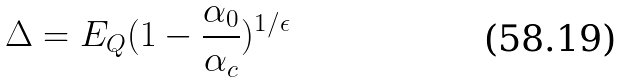Convert formula to latex. <formula><loc_0><loc_0><loc_500><loc_500>\Delta = E _ { Q } ( 1 - \frac { \alpha _ { 0 } } { \alpha _ { c } } ) ^ { 1 / \epsilon }</formula> 